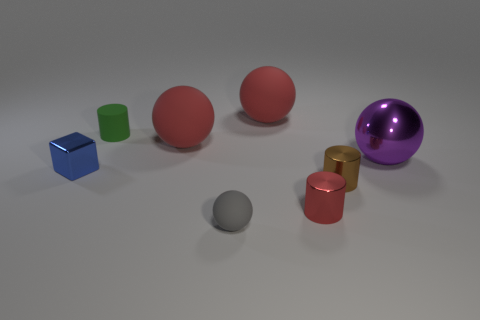Subtract all metallic cylinders. How many cylinders are left? 1 Subtract all blocks. How many objects are left? 7 Subtract all green cylinders. How many cylinders are left? 2 Add 4 red spheres. How many red spheres exist? 6 Add 1 large matte blocks. How many objects exist? 9 Subtract 0 brown spheres. How many objects are left? 8 Subtract 2 cylinders. How many cylinders are left? 1 Subtract all red spheres. Subtract all cyan blocks. How many spheres are left? 2 Subtract all cyan cylinders. How many yellow balls are left? 0 Subtract all gray rubber cylinders. Subtract all tiny blue shiny things. How many objects are left? 7 